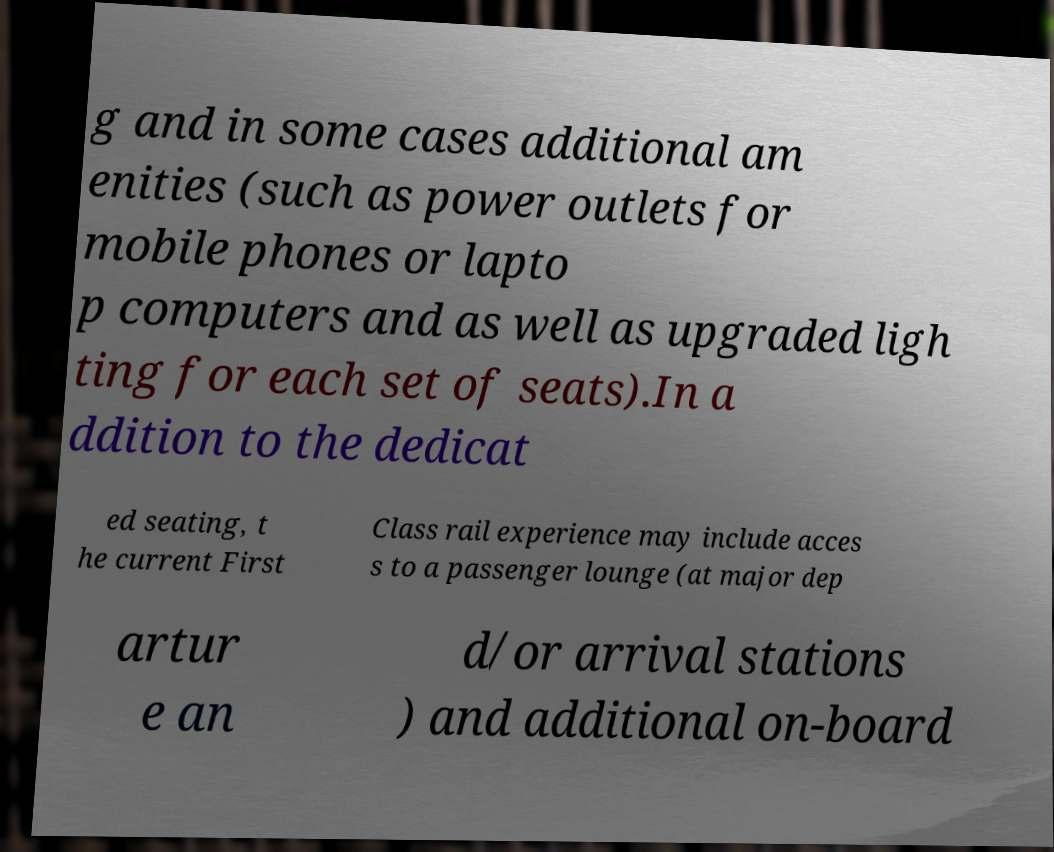Could you assist in decoding the text presented in this image and type it out clearly? g and in some cases additional am enities (such as power outlets for mobile phones or lapto p computers and as well as upgraded ligh ting for each set of seats).In a ddition to the dedicat ed seating, t he current First Class rail experience may include acces s to a passenger lounge (at major dep artur e an d/or arrival stations ) and additional on-board 